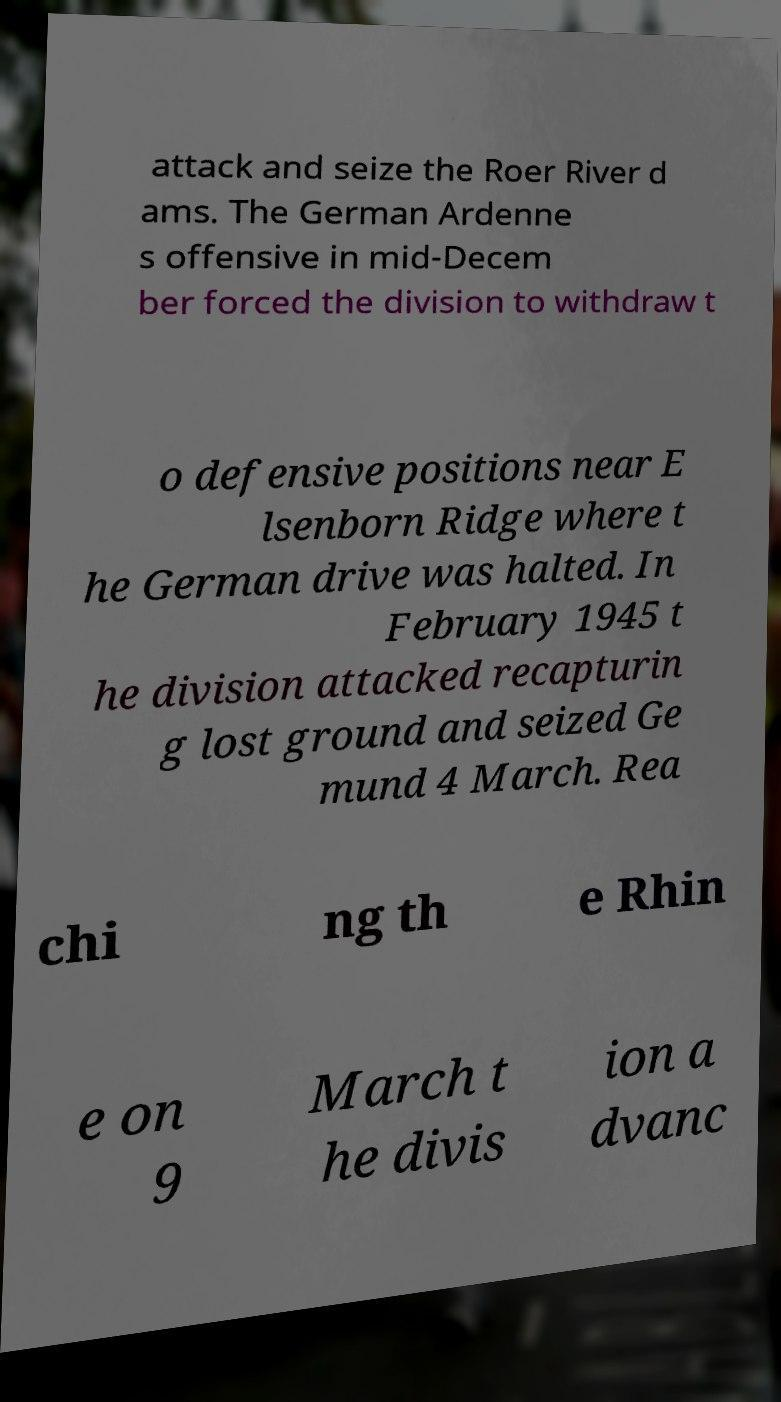Please identify and transcribe the text found in this image. attack and seize the Roer River d ams. The German Ardenne s offensive in mid-Decem ber forced the division to withdraw t o defensive positions near E lsenborn Ridge where t he German drive was halted. In February 1945 t he division attacked recapturin g lost ground and seized Ge mund 4 March. Rea chi ng th e Rhin e on 9 March t he divis ion a dvanc 